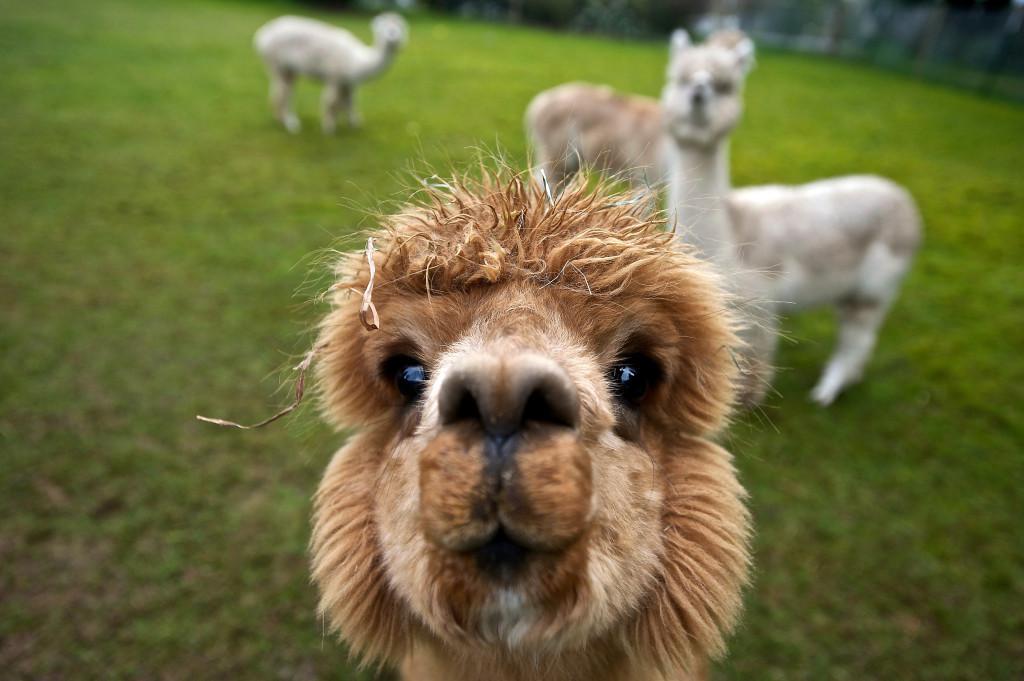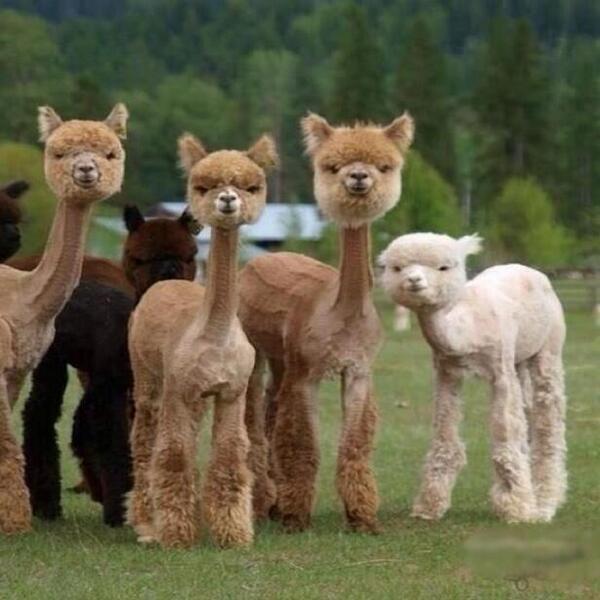The first image is the image on the left, the second image is the image on the right. Given the left and right images, does the statement "The right image contains exactly three llamas with heads close together, one of them white, and the left image shows two heads close together, at least one belonging to a light-colored llama." hold true? Answer yes or no. No. The first image is the image on the left, the second image is the image on the right. Analyze the images presented: Is the assertion "There are at most 4 llamas in the pair of images." valid? Answer yes or no. No. 